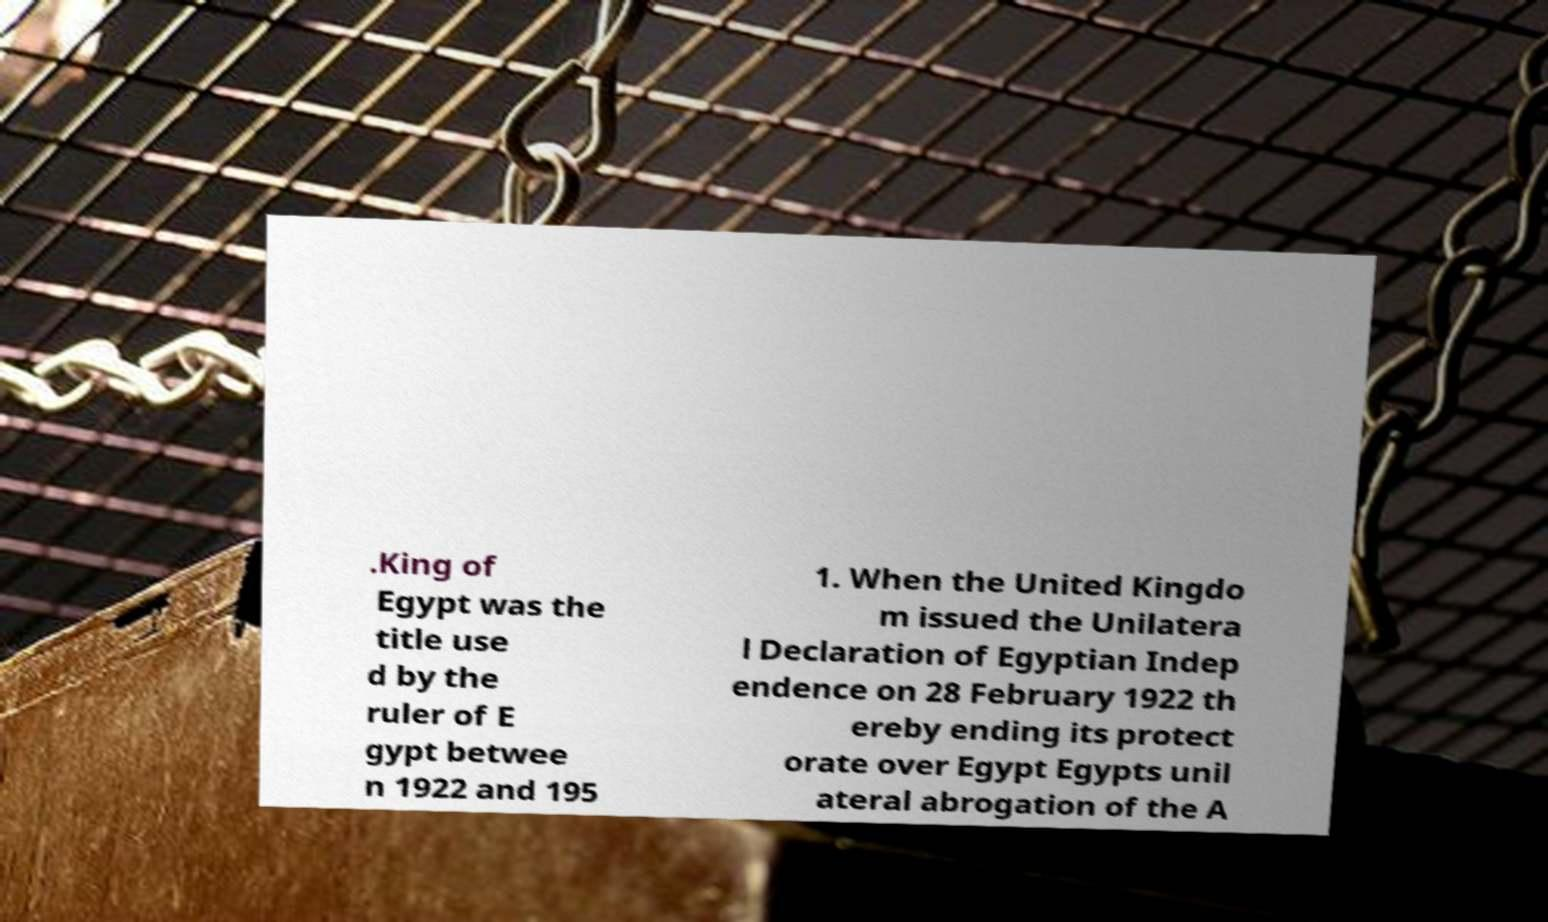Can you read and provide the text displayed in the image?This photo seems to have some interesting text. Can you extract and type it out for me? .King of Egypt was the title use d by the ruler of E gypt betwee n 1922 and 195 1. When the United Kingdo m issued the Unilatera l Declaration of Egyptian Indep endence on 28 February 1922 th ereby ending its protect orate over Egypt Egypts unil ateral abrogation of the A 